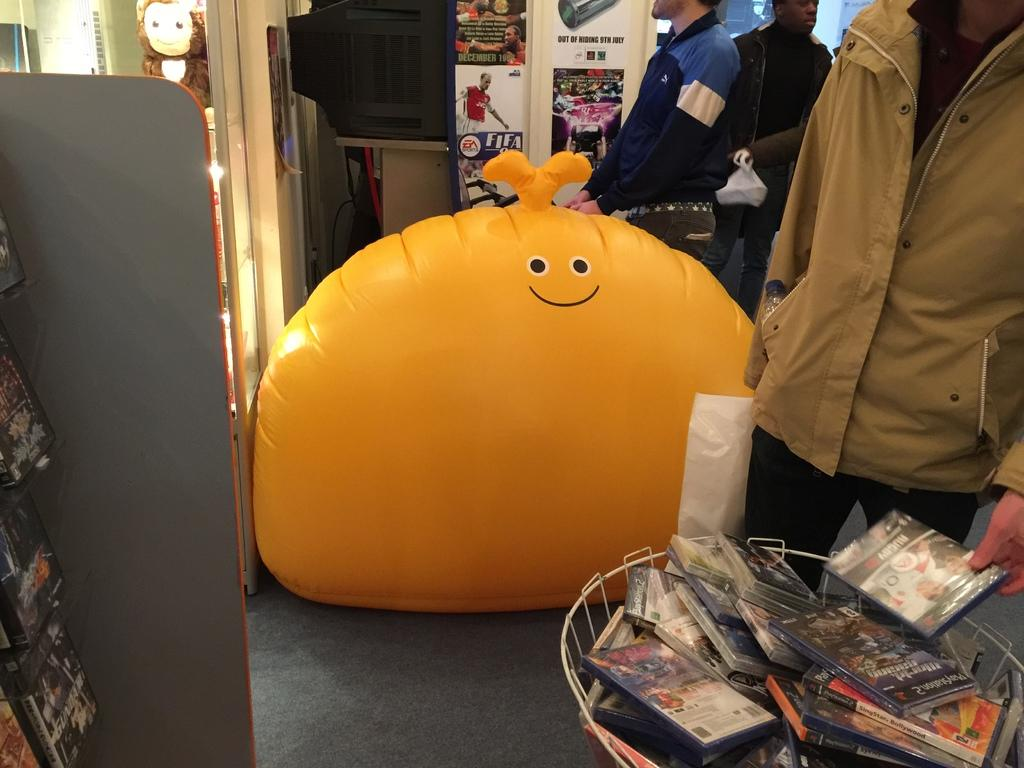<image>
Offer a succinct explanation of the picture presented. A man stands in front of basket of console games with a rugby game in his hand. 